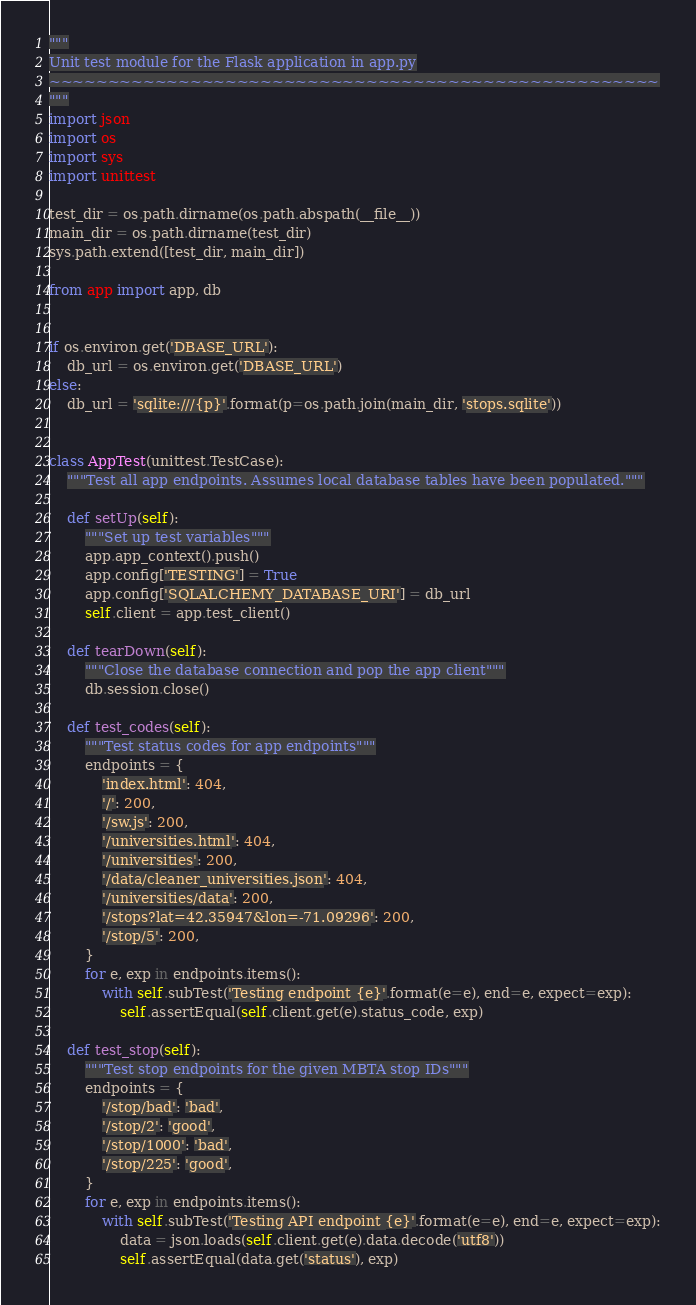<code> <loc_0><loc_0><loc_500><loc_500><_Python_>"""
Unit test module for the Flask application in app.py
~~~~~~~~~~~~~~~~~~~~~~~~~~~~~~~~~~~~~~~~~~~~~~~~~~~~
"""
import json
import os
import sys
import unittest

test_dir = os.path.dirname(os.path.abspath(__file__))
main_dir = os.path.dirname(test_dir)
sys.path.extend([test_dir, main_dir])

from app import app, db


if os.environ.get('DBASE_URL'):
    db_url = os.environ.get('DBASE_URL')
else:
    db_url = 'sqlite:///{p}'.format(p=os.path.join(main_dir, 'stops.sqlite'))


class AppTest(unittest.TestCase):
    """Test all app endpoints. Assumes local database tables have been populated."""

    def setUp(self):
        """Set up test variables"""
        app.app_context().push()
        app.config['TESTING'] = True
        app.config['SQLALCHEMY_DATABASE_URI'] = db_url
        self.client = app.test_client()

    def tearDown(self):
        """Close the database connection and pop the app client"""
        db.session.close()

    def test_codes(self):
        """Test status codes for app endpoints"""
        endpoints = {
            'index.html': 404,
            '/': 200,
            '/sw.js': 200,
            '/universities.html': 404,
            '/universities': 200,
            '/data/cleaner_universities.json': 404,
            '/universities/data': 200,
            '/stops?lat=42.35947&lon=-71.09296': 200,
            '/stop/5': 200,
        }
        for e, exp in endpoints.items():
            with self.subTest('Testing endpoint {e}'.format(e=e), end=e, expect=exp):
                self.assertEqual(self.client.get(e).status_code, exp)

    def test_stop(self):
        """Test stop endpoints for the given MBTA stop IDs"""
        endpoints = {
            '/stop/bad': 'bad',
            '/stop/2': 'good',
            '/stop/1000': 'bad',
            '/stop/225': 'good',
        }
        for e, exp in endpoints.items():
            with self.subTest('Testing API endpoint {e}'.format(e=e), end=e, expect=exp):
                data = json.loads(self.client.get(e).data.decode('utf8'))
                self.assertEqual(data.get('status'), exp)
</code> 